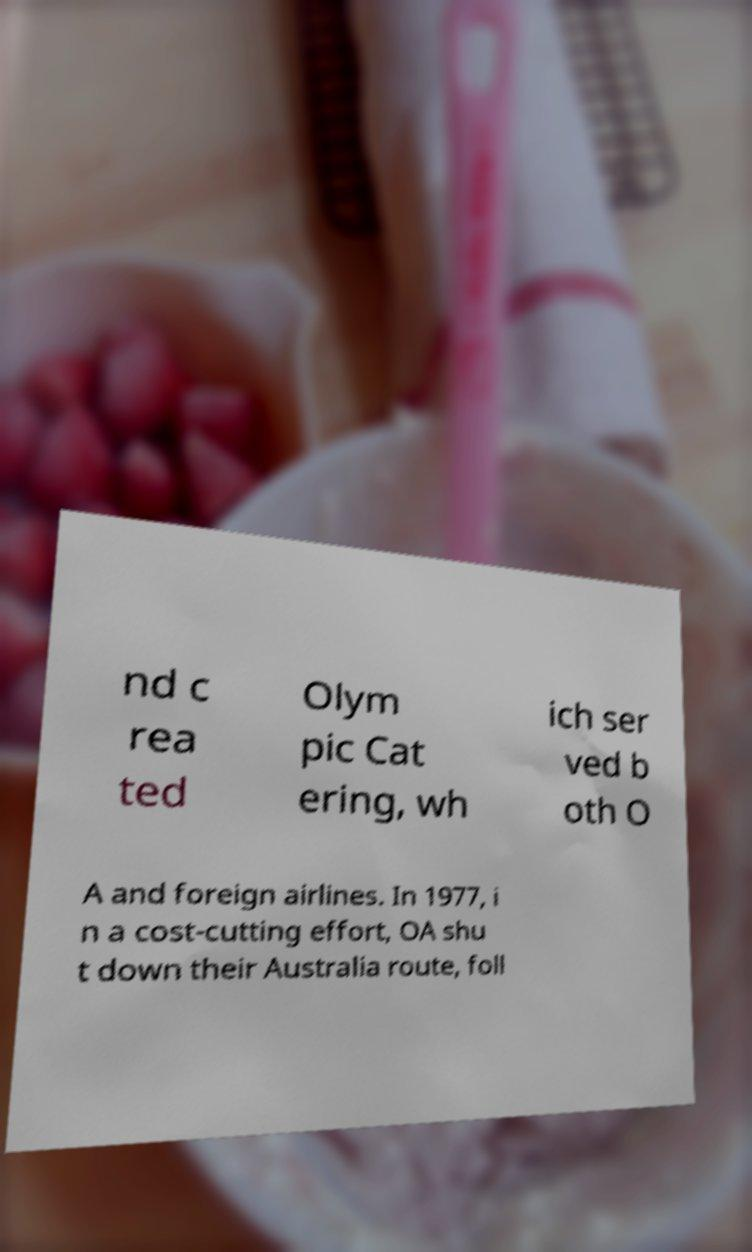Can you accurately transcribe the text from the provided image for me? nd c rea ted Olym pic Cat ering, wh ich ser ved b oth O A and foreign airlines. In 1977, i n a cost-cutting effort, OA shu t down their Australia route, foll 